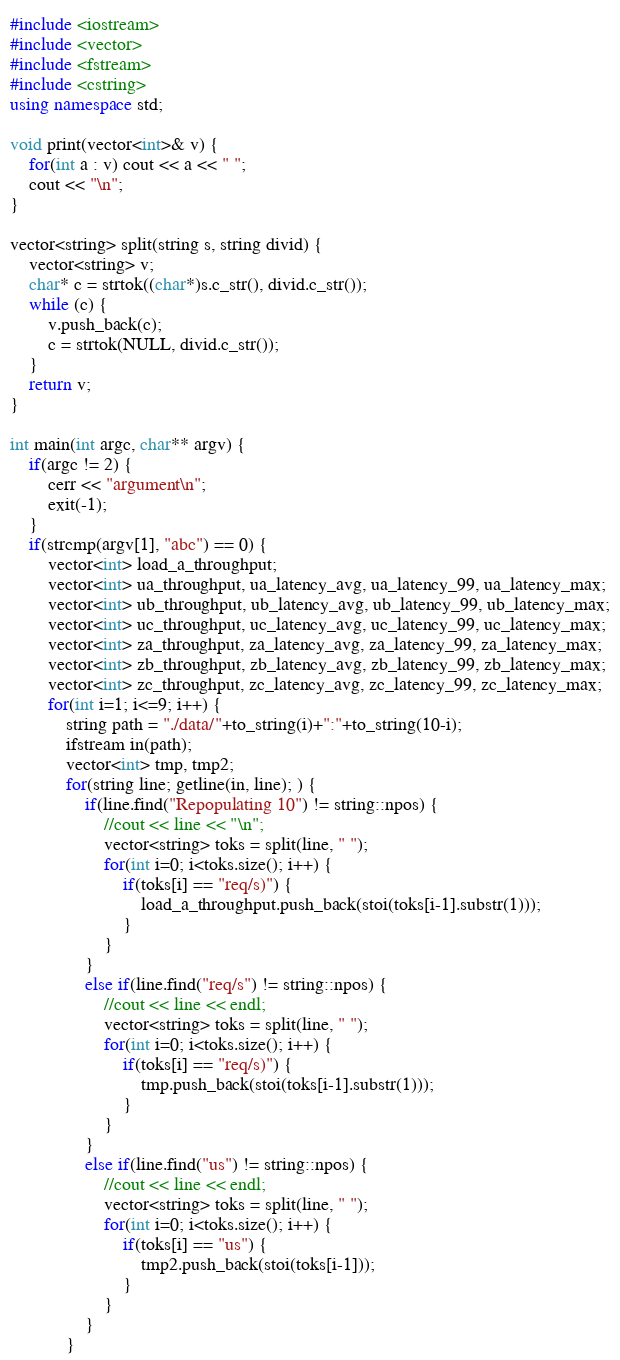<code> <loc_0><loc_0><loc_500><loc_500><_C++_>#include <iostream>
#include <vector>
#include <fstream>
#include <cstring>
using namespace std;

void print(vector<int>& v) {
	for(int a : v) cout << a << " ";
	cout << "\n";
}

vector<string> split(string s, string divid) {
	vector<string> v;
	char* c = strtok((char*)s.c_str(), divid.c_str());
	while (c) {
		v.push_back(c);
		c = strtok(NULL, divid.c_str());
	}
	return v;
}

int main(int argc, char** argv) {
	if(argc != 2) {
		cerr << "argument\n";
		exit(-1);
	}
	if(strcmp(argv[1], "abc") == 0) {
		vector<int> load_a_throughput;
		vector<int> ua_throughput, ua_latency_avg, ua_latency_99, ua_latency_max;
		vector<int> ub_throughput, ub_latency_avg, ub_latency_99, ub_latency_max;
		vector<int> uc_throughput, uc_latency_avg, uc_latency_99, uc_latency_max;
		vector<int> za_throughput, za_latency_avg, za_latency_99, za_latency_max;
		vector<int> zb_throughput, zb_latency_avg, zb_latency_99, zb_latency_max;
		vector<int> zc_throughput, zc_latency_avg, zc_latency_99, zc_latency_max;
		for(int i=1; i<=9; i++) {
			string path = "./data/"+to_string(i)+":"+to_string(10-i);
			ifstream in(path);		
			vector<int> tmp, tmp2;
			for(string line; getline(in, line); ) {
				if(line.find("Repopulating 10") != string::npos) {
					//cout << line << "\n";
					vector<string> toks = split(line, " ");					
					for(int i=0; i<toks.size(); i++) {
						if(toks[i] == "req/s)") {
							load_a_throughput.push_back(stoi(toks[i-1].substr(1)));
						}
					}
				}
				else if(line.find("req/s") != string::npos) {
					//cout << line << endl;
					vector<string> toks = split(line, " ");					
					for(int i=0; i<toks.size(); i++) {
						if(toks[i] == "req/s)") {
							tmp.push_back(stoi(toks[i-1].substr(1)));
						}
					}
				}
				else if(line.find("us") != string::npos) {
					//cout << line << endl;
					vector<string> toks = split(line, " ");					
					for(int i=0; i<toks.size(); i++) {
						if(toks[i] == "us") {
							tmp2.push_back(stoi(toks[i-1]));
						}
					}
				}
			}</code> 